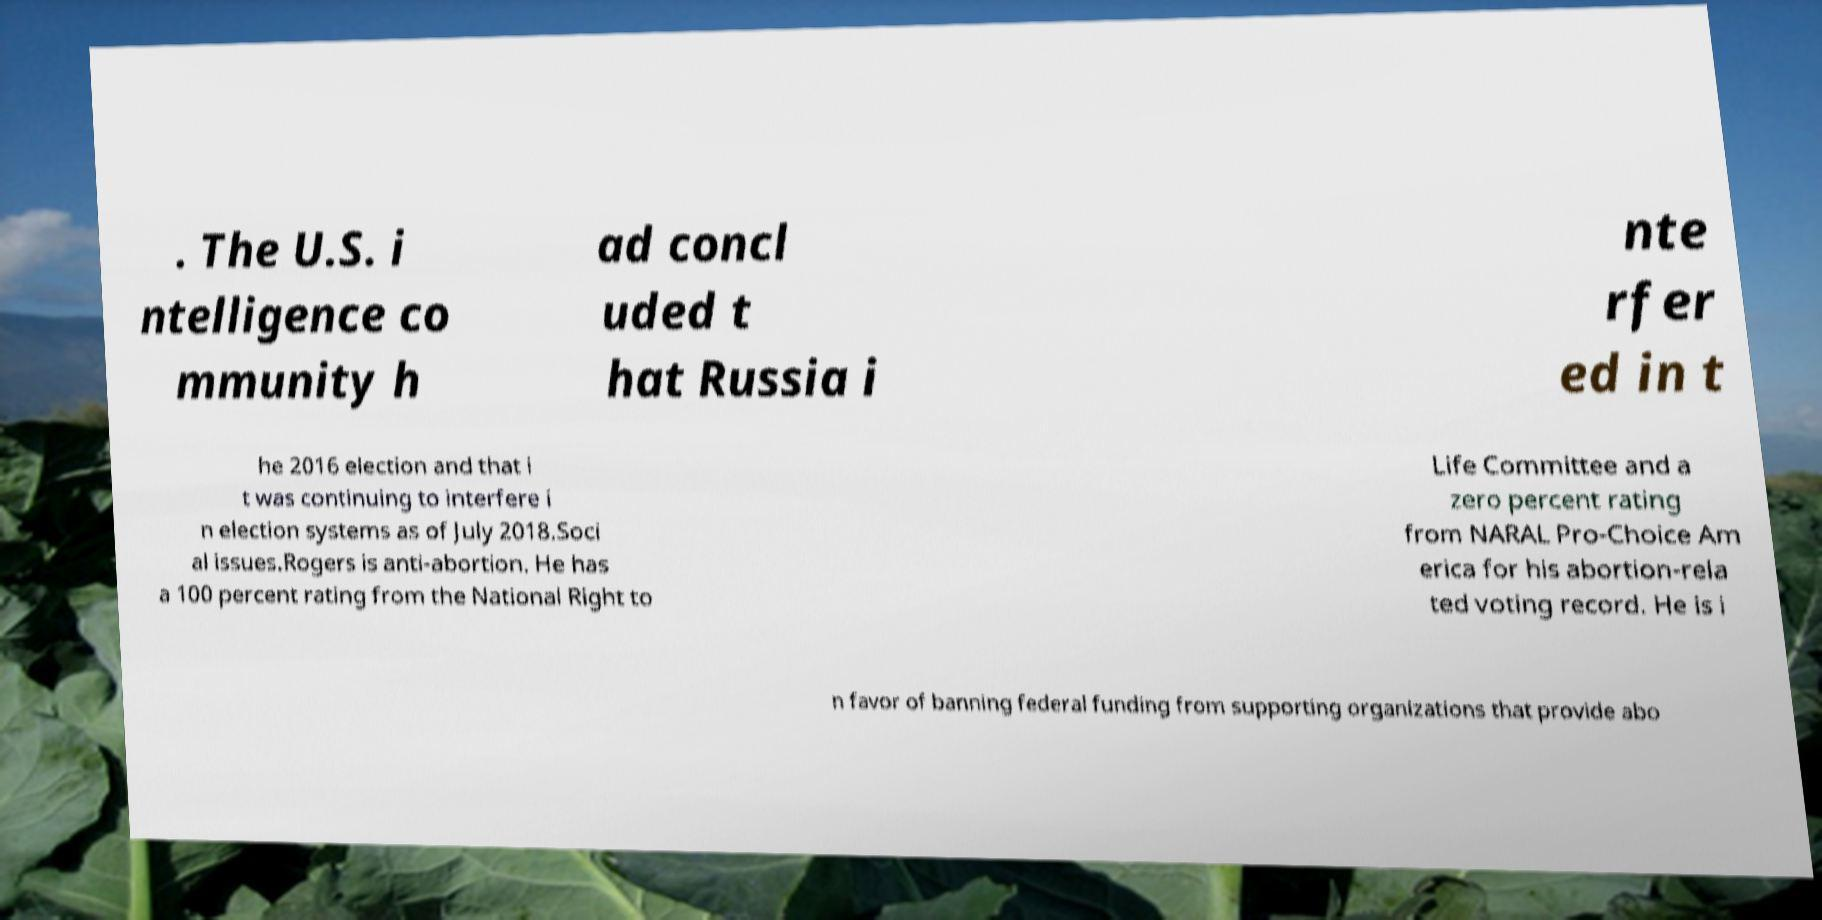Could you extract and type out the text from this image? . The U.S. i ntelligence co mmunity h ad concl uded t hat Russia i nte rfer ed in t he 2016 election and that i t was continuing to interfere i n election systems as of July 2018.Soci al issues.Rogers is anti-abortion. He has a 100 percent rating from the National Right to Life Committee and a zero percent rating from NARAL Pro-Choice Am erica for his abortion-rela ted voting record. He is i n favor of banning federal funding from supporting organizations that provide abo 